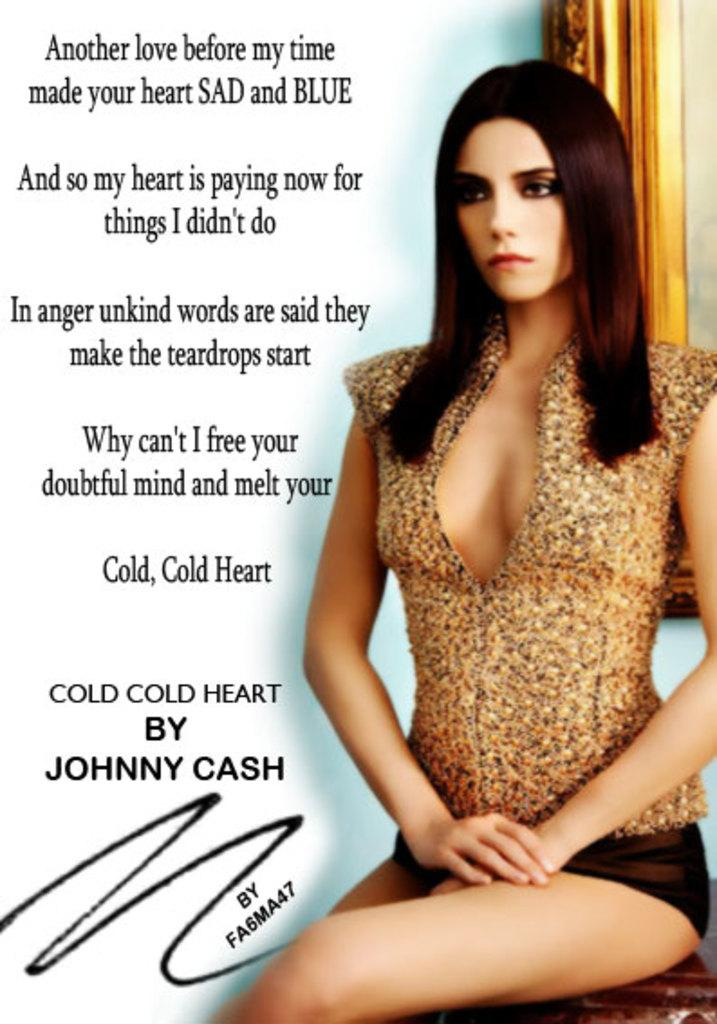What is the woman doing in the image? The woman is sitting in the image. What is the woman sitting on? The woman is sitting on a wooden surface. Can you describe any other objects or features in the image? There is a frame and some text in the image. What type of competition is the woman participating in within the image? There is no competition present in the image; it simply shows a woman sitting on a wooden surface with a frame and some text. How many robins can be seen in the image? There are no robins present in the image. 